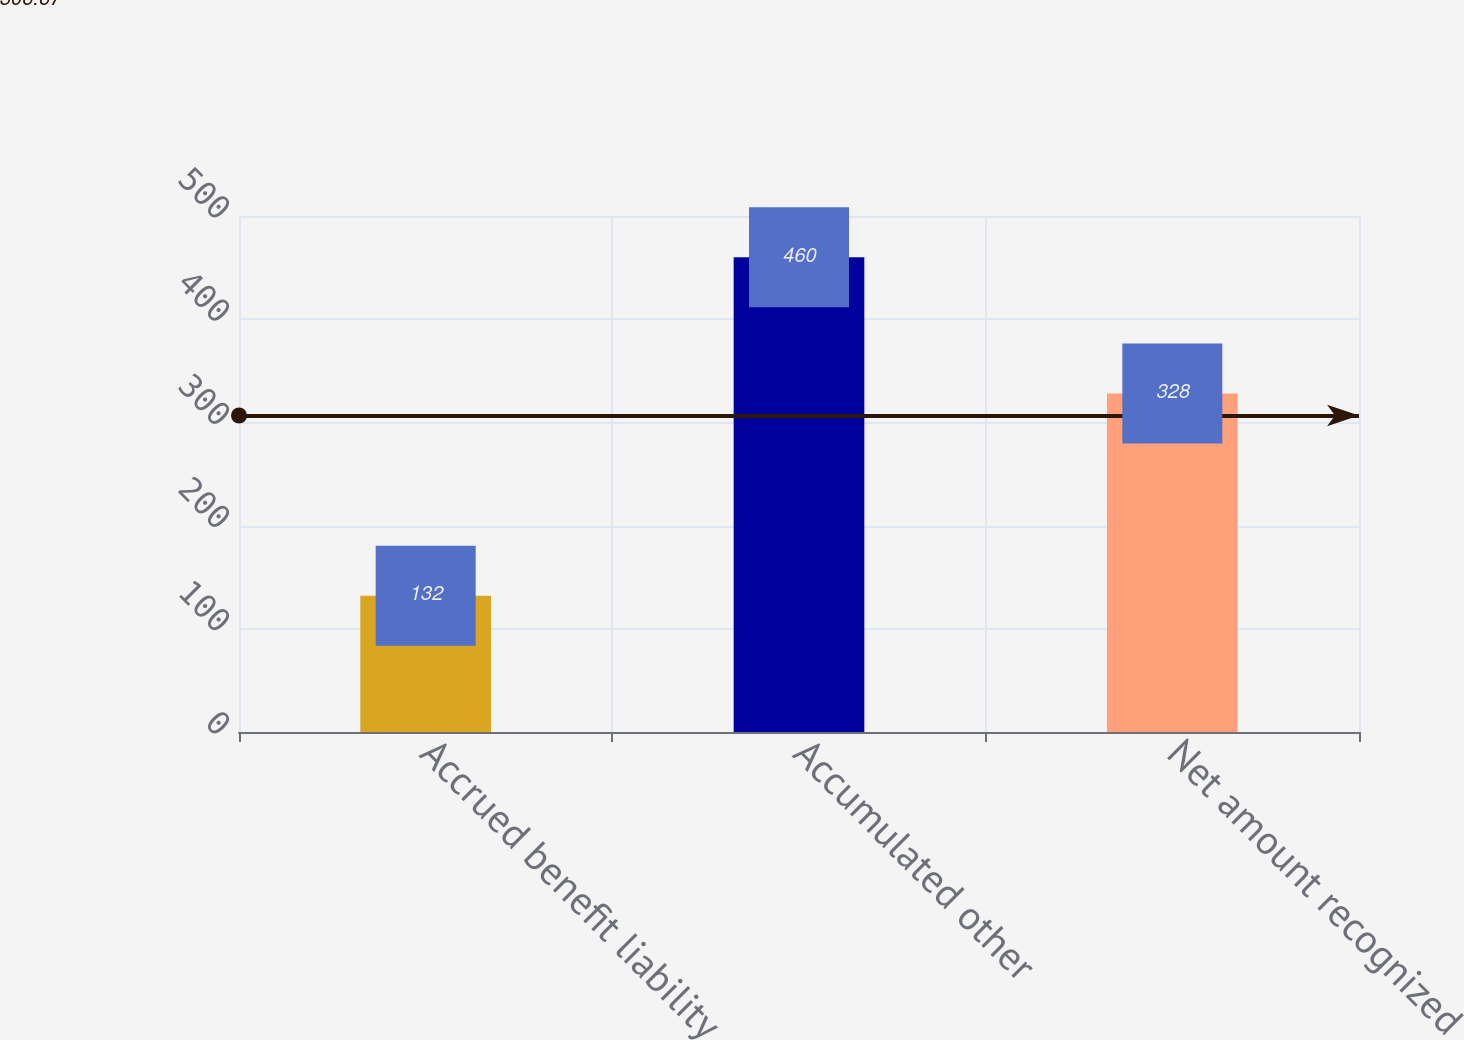<chart> <loc_0><loc_0><loc_500><loc_500><bar_chart><fcel>Accrued benefit liability<fcel>Accumulated other<fcel>Net amount recognized<nl><fcel>132<fcel>460<fcel>328<nl></chart> 